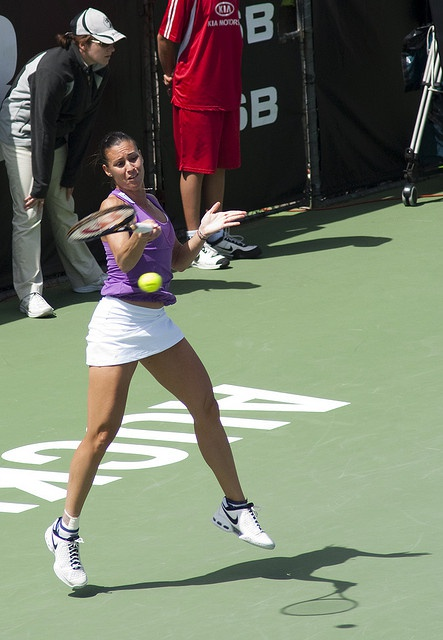Describe the objects in this image and their specific colors. I can see people in black, maroon, white, gray, and darkgray tones, people in black, gray, lightgray, and darkgray tones, people in black, maroon, and brown tones, tennis racket in black, darkgray, gray, and tan tones, and sports ball in black, khaki, and olive tones in this image. 